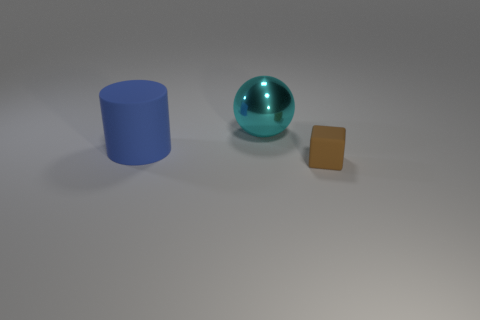Add 1 large cylinders. How many objects exist? 4 Subtract all balls. How many objects are left? 2 Subtract all matte cylinders. Subtract all small cyan metal spheres. How many objects are left? 2 Add 2 big balls. How many big balls are left? 3 Add 3 blue shiny blocks. How many blue shiny blocks exist? 3 Subtract 1 blue cylinders. How many objects are left? 2 Subtract 1 cylinders. How many cylinders are left? 0 